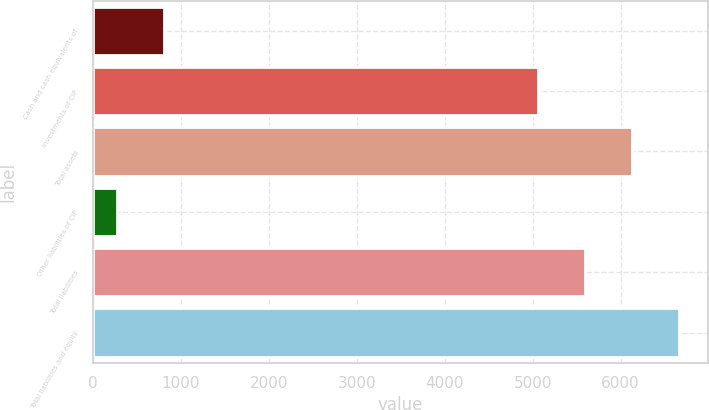<chart> <loc_0><loc_0><loc_500><loc_500><bar_chart><fcel>Cash and cash equivalents of<fcel>Investments of CIP<fcel>Total assets<fcel>Other liabilities of CIP<fcel>Total liabilities<fcel>Total liabilities and equity<nl><fcel>809.46<fcel>5063.5<fcel>6127.62<fcel>277.4<fcel>5595.56<fcel>6659.68<nl></chart> 